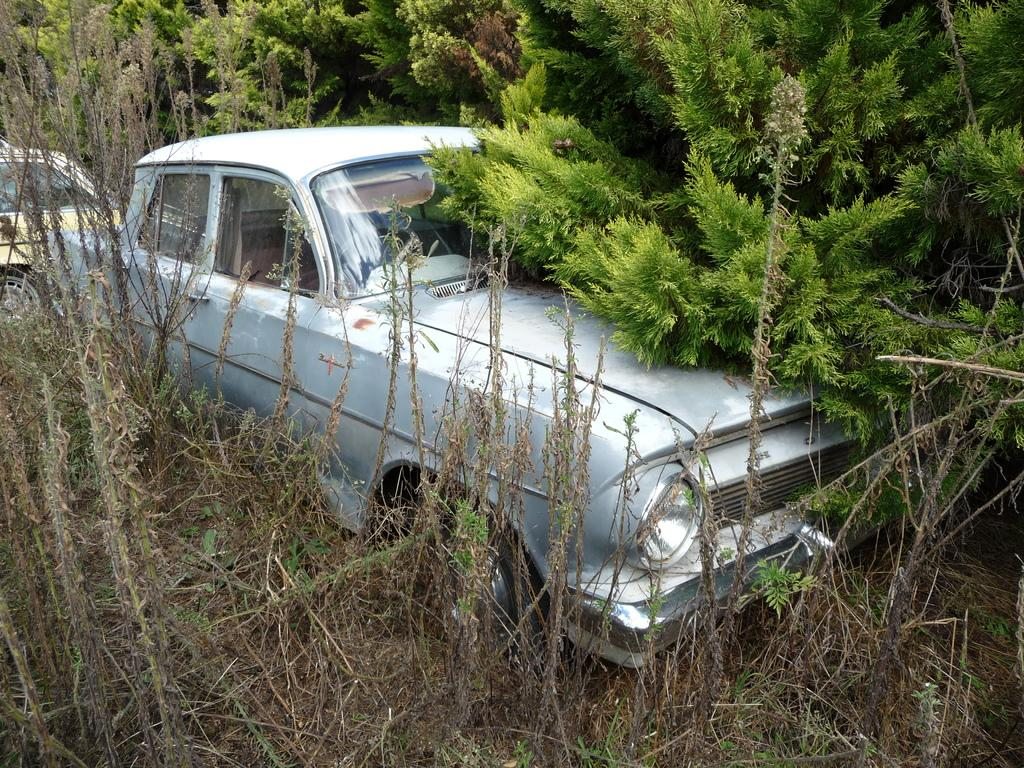What are the main subjects in the center of the image? There are two cars in the center of the image. What can be seen in the background of the image? There are trees and plants in the background of the image. What type of duck can be seen in the image? There is no duck present in the image. What is the lawyer doing in the image? There is no lawyer present in the image. 